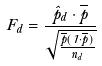<formula> <loc_0><loc_0><loc_500><loc_500>F _ { d } = \frac { \hat { p } _ { d } \cdot \overline { p } } { \sqrt { \frac { \overline { p } ( 1 \cdot \overline { p } ) } { n _ { d } } } }</formula> 